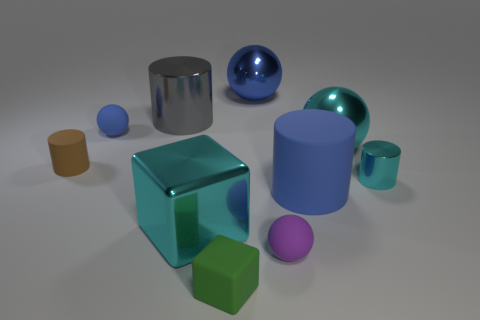Subtract all gray cylinders. How many cylinders are left? 3 Subtract all big blue metal balls. How many balls are left? 3 Subtract 1 spheres. How many spheres are left? 3 Subtract all gray cubes. Subtract all gray cylinders. How many cubes are left? 2 Subtract all blue cylinders. How many cyan blocks are left? 1 Add 8 small purple spheres. How many small purple spheres exist? 9 Subtract 0 blue blocks. How many objects are left? 10 Subtract all spheres. How many objects are left? 6 Subtract all cyan cylinders. Subtract all tiny brown rubber cylinders. How many objects are left? 8 Add 6 green blocks. How many green blocks are left? 7 